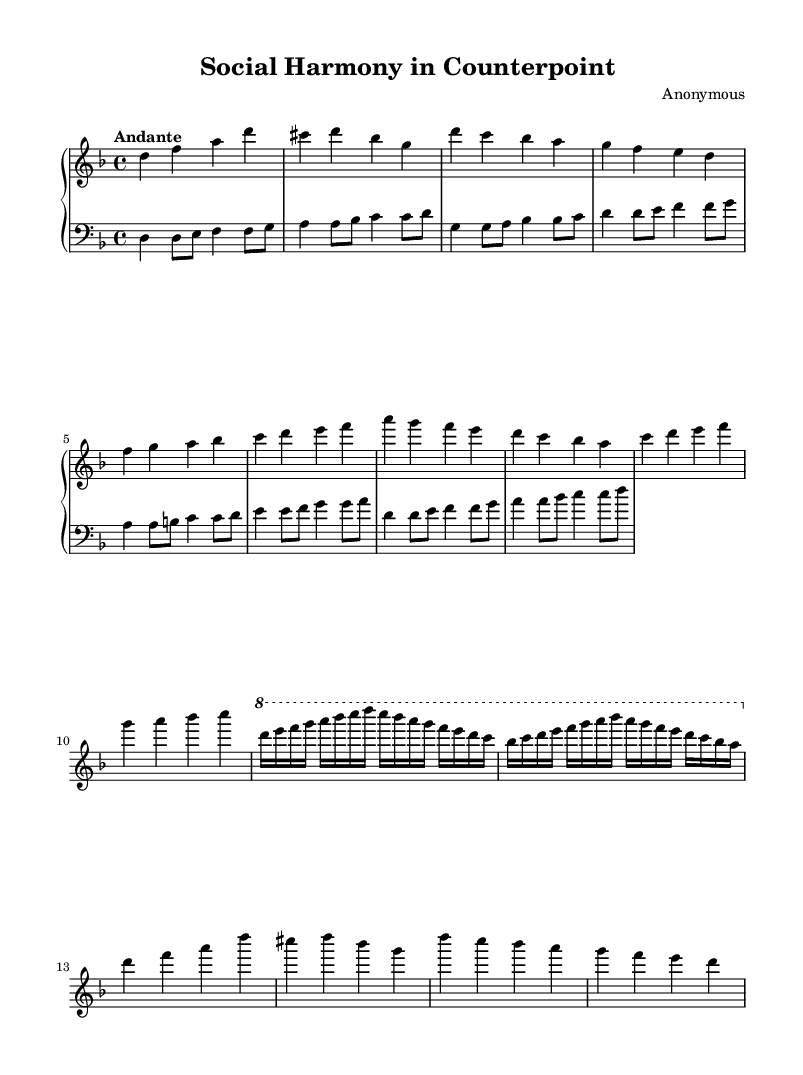What is the key signature of this music? The key signature of the music is indicated at the beginning of the score, showing one flat. In this case, the key signature corresponds to D minor.
Answer: D minor What is the time signature of this piece? The time signature is found at the beginning of the score, represented as a 4 over 4. This signifies that there are four beats in each measure, and the quarter note gets one beat.
Answer: 4/4 What is the tempo marking of this composition? The tempo marking appears in the score above the staff and indicates the desired speed of the piece; in this case, it states “Andante,” which means a moderate pace.
Answer: Andante How many themes are introduced in this music? By examining the structure of the piece, we can identify two main themes, labeled Theme A and Theme B. Each theme presents distinct melodic ideas.
Answer: 2 Which section of the composition does not introduce new material? The recapitulation section brings back the initial thematic material instead of introducing anything new. This is typical in the structure of Baroque compositions.
Answer: Recapitulation What is the texture of this Baroque organ work? The texture of this piece can be considered polyphonic, as it features multiple independent voices that interact with each other, which is characteristic of Baroque music.
Answer: Polyphonic 